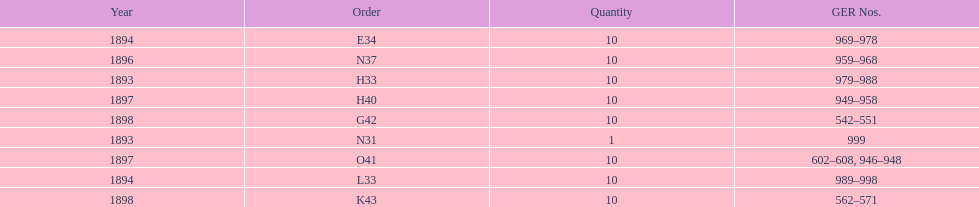Which year had the least ger numbers? 1893. 